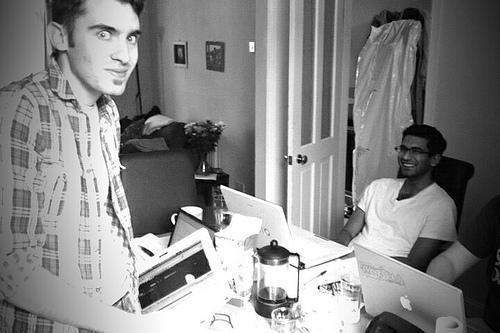How many people are pictured sitting down?
Give a very brief answer. 1. How many people are there?
Give a very brief answer. 2. How many laptops can you see?
Give a very brief answer. 2. 